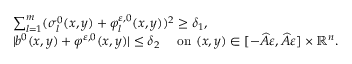Convert formula to latex. <formula><loc_0><loc_0><loc_500><loc_500>\begin{array} { r l } & { \sum _ { l = 1 } ^ { m } ( \sigma _ { l } ^ { 0 } ( x , y ) + \varphi _ { l } ^ { \varepsilon , 0 } ( x , y ) ) ^ { 2 } \geq \delta _ { 1 } , } \\ & { | b ^ { 0 } ( x , y ) + \varphi ^ { \varepsilon , 0 } ( x , y ) | \leq \delta _ { 2 } \quad o n ( x , y ) \in [ - \widehat { A } \varepsilon , \widehat { A } \varepsilon ] \times \mathbb { R } ^ { n } . } \end{array}</formula> 